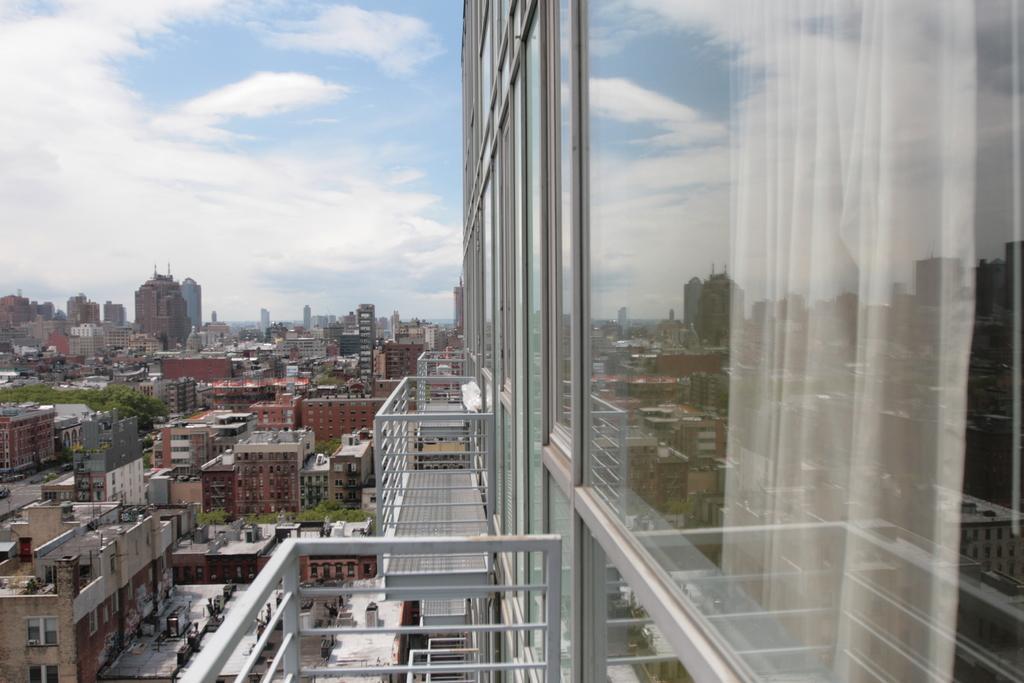In one or two sentences, can you explain what this image depicts? In this picture I can see trees and buildings. On the buildings I can see some objects. On the right side I can see framed glass wall. Inside the building I can see white color curtain. Here we have balconies. In the background I can see the sky. 